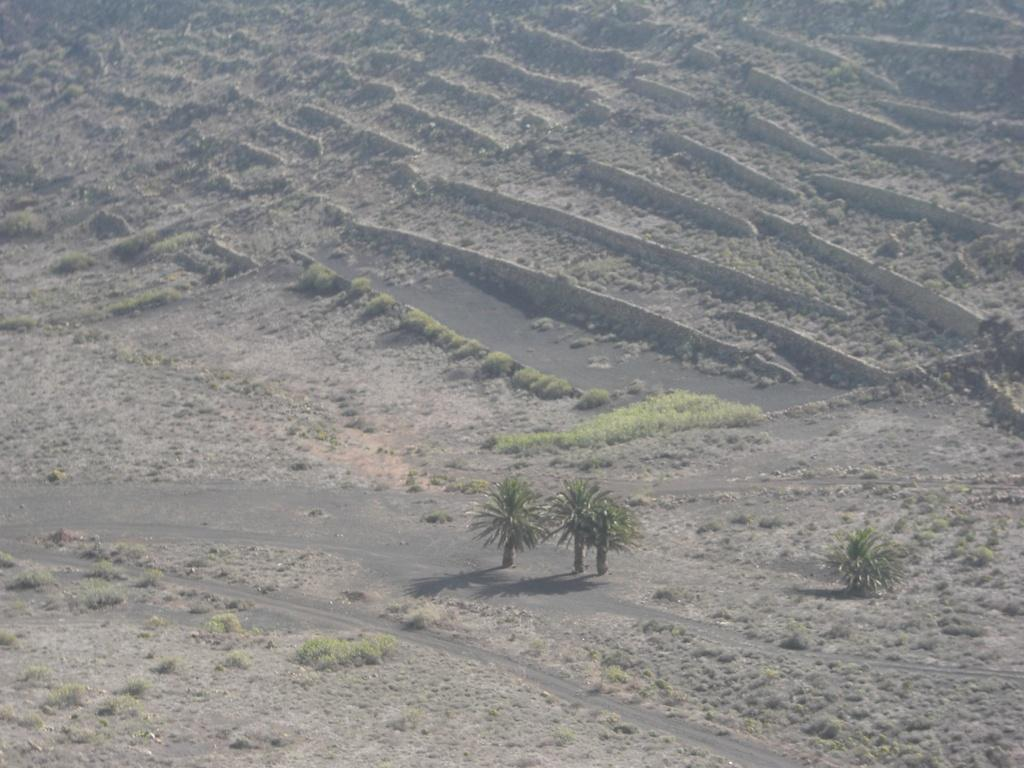What type of living organisms can be seen in the image? Plants can be seen in the image. What type of terrain is visible in the image? There is land visible in the image. How does the walk of the plants affect their digestion in the image? There are no plants walking or having digestion in the image, as plants do not have the ability to walk or digest like animals. 